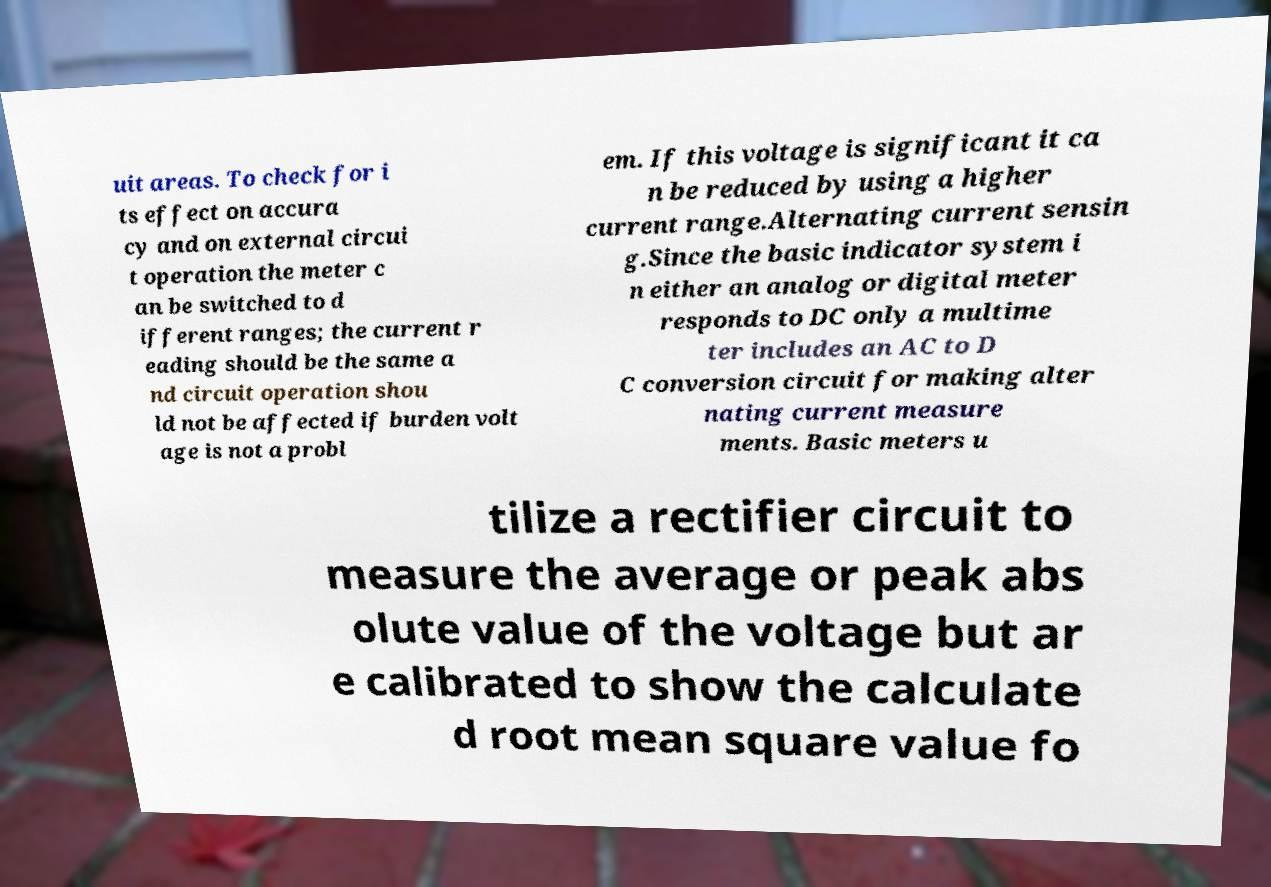Can you accurately transcribe the text from the provided image for me? uit areas. To check for i ts effect on accura cy and on external circui t operation the meter c an be switched to d ifferent ranges; the current r eading should be the same a nd circuit operation shou ld not be affected if burden volt age is not a probl em. If this voltage is significant it ca n be reduced by using a higher current range.Alternating current sensin g.Since the basic indicator system i n either an analog or digital meter responds to DC only a multime ter includes an AC to D C conversion circuit for making alter nating current measure ments. Basic meters u tilize a rectifier circuit to measure the average or peak abs olute value of the voltage but ar e calibrated to show the calculate d root mean square value fo 